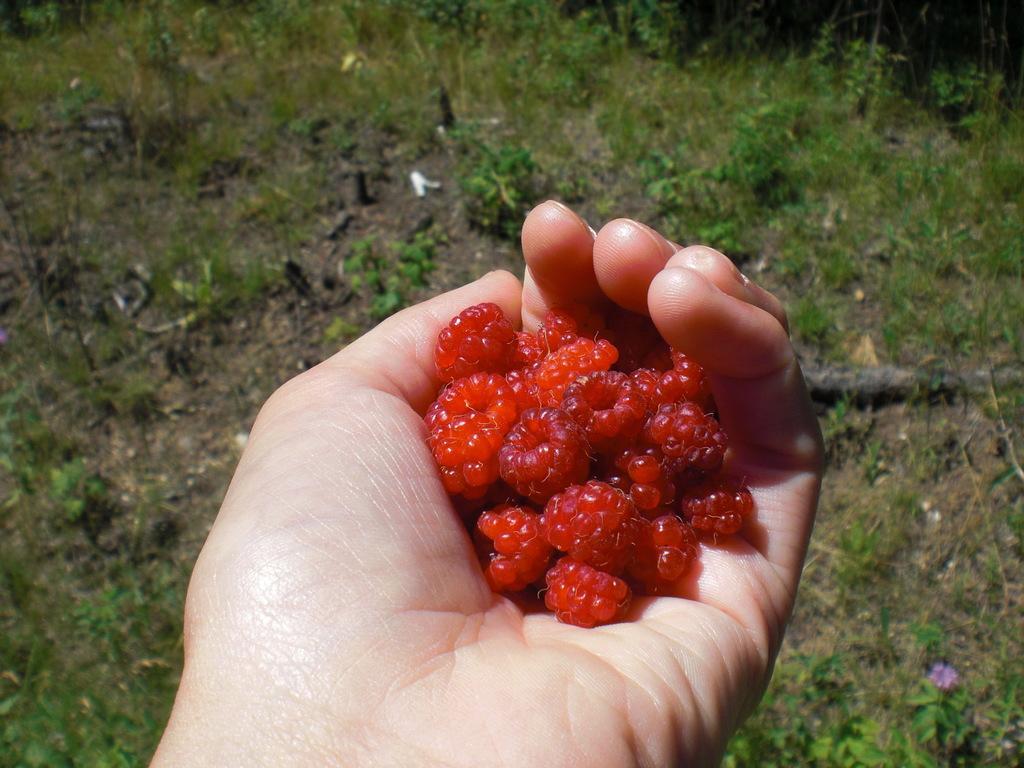In one or two sentences, can you explain what this image depicts? There is a person holding red color fruits with a hand. In the background, there are plants and grass on the ground. 